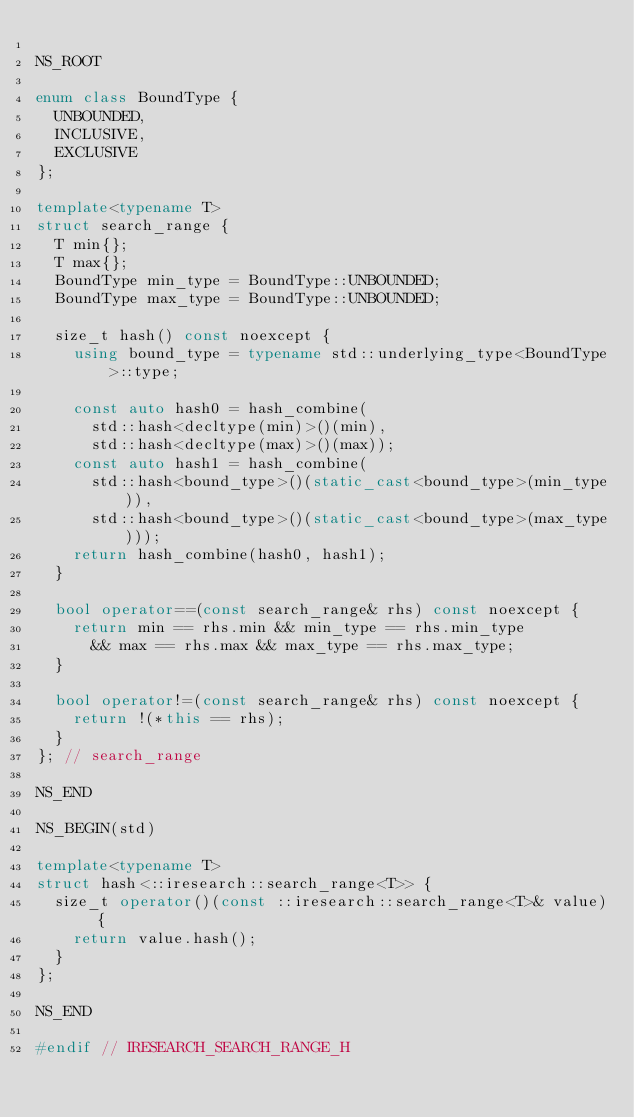Convert code to text. <code><loc_0><loc_0><loc_500><loc_500><_C++_>
NS_ROOT

enum class BoundType {
  UNBOUNDED,
  INCLUSIVE,
  EXCLUSIVE
};

template<typename T>
struct search_range {
  T min{};
  T max{};
  BoundType min_type = BoundType::UNBOUNDED;
  BoundType max_type = BoundType::UNBOUNDED;

  size_t hash() const noexcept {
    using bound_type = typename std::underlying_type<BoundType>::type;

    const auto hash0 = hash_combine(
      std::hash<decltype(min)>()(min),
      std::hash<decltype(max)>()(max));
    const auto hash1 = hash_combine(
      std::hash<bound_type>()(static_cast<bound_type>(min_type)),
      std::hash<bound_type>()(static_cast<bound_type>(max_type)));
    return hash_combine(hash0, hash1);
  }

  bool operator==(const search_range& rhs) const noexcept {
    return min == rhs.min && min_type == rhs.min_type
      && max == rhs.max && max_type == rhs.max_type;
  }

  bool operator!=(const search_range& rhs) const noexcept {
    return !(*this == rhs);
  }
}; // search_range

NS_END

NS_BEGIN(std)

template<typename T>
struct hash<::iresearch::search_range<T>> {
  size_t operator()(const ::iresearch::search_range<T>& value) {
    return value.hash();
  }
};

NS_END

#endif // IRESEARCH_SEARCH_RANGE_H
</code> 